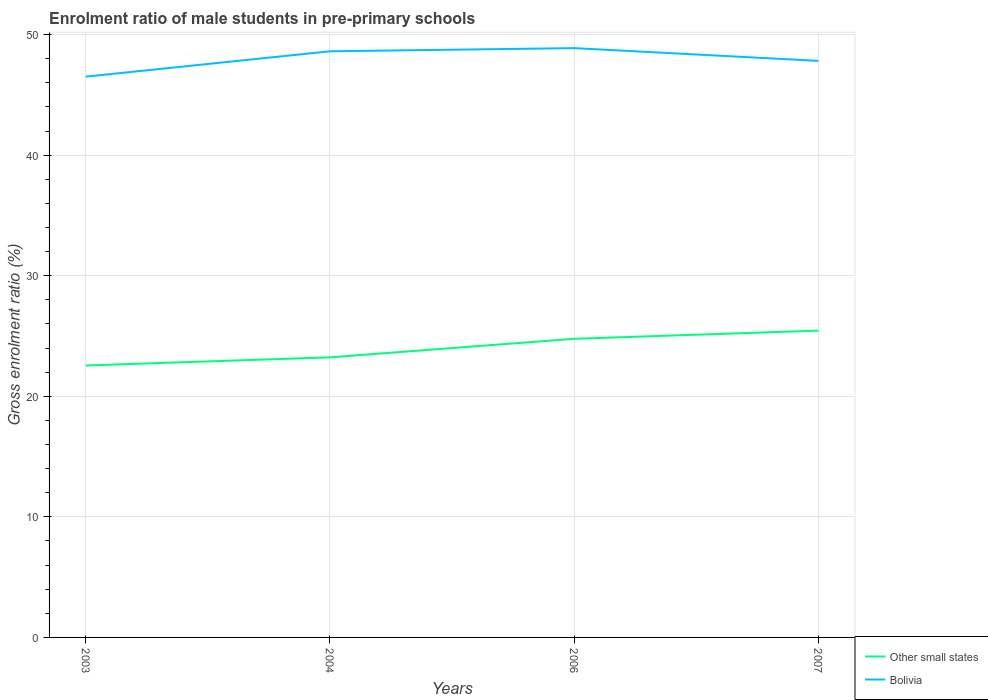How many different coloured lines are there?
Offer a terse response. 2. Is the number of lines equal to the number of legend labels?
Offer a very short reply. Yes. Across all years, what is the maximum enrolment ratio of male students in pre-primary schools in Other small states?
Ensure brevity in your answer.  22.55. What is the total enrolment ratio of male students in pre-primary schools in Other small states in the graph?
Your response must be concise. -2.22. What is the difference between the highest and the second highest enrolment ratio of male students in pre-primary schools in Bolivia?
Ensure brevity in your answer.  2.37. What is the difference between the highest and the lowest enrolment ratio of male students in pre-primary schools in Bolivia?
Offer a very short reply. 2. How many lines are there?
Your answer should be very brief. 2. What is the difference between two consecutive major ticks on the Y-axis?
Offer a very short reply. 10. Are the values on the major ticks of Y-axis written in scientific E-notation?
Give a very brief answer. No. Does the graph contain any zero values?
Give a very brief answer. No. What is the title of the graph?
Give a very brief answer. Enrolment ratio of male students in pre-primary schools. Does "Micronesia" appear as one of the legend labels in the graph?
Keep it short and to the point. No. What is the Gross enrolment ratio (%) of Other small states in 2003?
Make the answer very short. 22.55. What is the Gross enrolment ratio (%) in Bolivia in 2003?
Ensure brevity in your answer.  46.51. What is the Gross enrolment ratio (%) in Other small states in 2004?
Provide a short and direct response. 23.23. What is the Gross enrolment ratio (%) in Bolivia in 2004?
Your answer should be compact. 48.61. What is the Gross enrolment ratio (%) of Other small states in 2006?
Keep it short and to the point. 24.77. What is the Gross enrolment ratio (%) in Bolivia in 2006?
Make the answer very short. 48.88. What is the Gross enrolment ratio (%) of Other small states in 2007?
Provide a succinct answer. 25.45. What is the Gross enrolment ratio (%) in Bolivia in 2007?
Give a very brief answer. 47.82. Across all years, what is the maximum Gross enrolment ratio (%) in Other small states?
Ensure brevity in your answer.  25.45. Across all years, what is the maximum Gross enrolment ratio (%) in Bolivia?
Keep it short and to the point. 48.88. Across all years, what is the minimum Gross enrolment ratio (%) in Other small states?
Offer a very short reply. 22.55. Across all years, what is the minimum Gross enrolment ratio (%) of Bolivia?
Your answer should be compact. 46.51. What is the total Gross enrolment ratio (%) of Other small states in the graph?
Keep it short and to the point. 96. What is the total Gross enrolment ratio (%) of Bolivia in the graph?
Give a very brief answer. 191.82. What is the difference between the Gross enrolment ratio (%) in Other small states in 2003 and that in 2004?
Your answer should be very brief. -0.68. What is the difference between the Gross enrolment ratio (%) of Bolivia in 2003 and that in 2004?
Your response must be concise. -2.1. What is the difference between the Gross enrolment ratio (%) in Other small states in 2003 and that in 2006?
Provide a succinct answer. -2.21. What is the difference between the Gross enrolment ratio (%) of Bolivia in 2003 and that in 2006?
Offer a very short reply. -2.37. What is the difference between the Gross enrolment ratio (%) of Other small states in 2003 and that in 2007?
Your answer should be compact. -2.89. What is the difference between the Gross enrolment ratio (%) in Bolivia in 2003 and that in 2007?
Provide a short and direct response. -1.31. What is the difference between the Gross enrolment ratio (%) of Other small states in 2004 and that in 2006?
Your answer should be compact. -1.54. What is the difference between the Gross enrolment ratio (%) of Bolivia in 2004 and that in 2006?
Your answer should be compact. -0.26. What is the difference between the Gross enrolment ratio (%) of Other small states in 2004 and that in 2007?
Your response must be concise. -2.22. What is the difference between the Gross enrolment ratio (%) in Bolivia in 2004 and that in 2007?
Offer a terse response. 0.79. What is the difference between the Gross enrolment ratio (%) in Other small states in 2006 and that in 2007?
Keep it short and to the point. -0.68. What is the difference between the Gross enrolment ratio (%) in Bolivia in 2006 and that in 2007?
Provide a short and direct response. 1.06. What is the difference between the Gross enrolment ratio (%) in Other small states in 2003 and the Gross enrolment ratio (%) in Bolivia in 2004?
Ensure brevity in your answer.  -26.06. What is the difference between the Gross enrolment ratio (%) in Other small states in 2003 and the Gross enrolment ratio (%) in Bolivia in 2006?
Your answer should be compact. -26.32. What is the difference between the Gross enrolment ratio (%) of Other small states in 2003 and the Gross enrolment ratio (%) of Bolivia in 2007?
Your answer should be compact. -25.26. What is the difference between the Gross enrolment ratio (%) in Other small states in 2004 and the Gross enrolment ratio (%) in Bolivia in 2006?
Your response must be concise. -25.64. What is the difference between the Gross enrolment ratio (%) in Other small states in 2004 and the Gross enrolment ratio (%) in Bolivia in 2007?
Offer a very short reply. -24.59. What is the difference between the Gross enrolment ratio (%) of Other small states in 2006 and the Gross enrolment ratio (%) of Bolivia in 2007?
Your response must be concise. -23.05. What is the average Gross enrolment ratio (%) of Other small states per year?
Provide a short and direct response. 24. What is the average Gross enrolment ratio (%) in Bolivia per year?
Offer a very short reply. 47.95. In the year 2003, what is the difference between the Gross enrolment ratio (%) in Other small states and Gross enrolment ratio (%) in Bolivia?
Keep it short and to the point. -23.95. In the year 2004, what is the difference between the Gross enrolment ratio (%) in Other small states and Gross enrolment ratio (%) in Bolivia?
Your response must be concise. -25.38. In the year 2006, what is the difference between the Gross enrolment ratio (%) of Other small states and Gross enrolment ratio (%) of Bolivia?
Give a very brief answer. -24.11. In the year 2007, what is the difference between the Gross enrolment ratio (%) in Other small states and Gross enrolment ratio (%) in Bolivia?
Ensure brevity in your answer.  -22.37. What is the ratio of the Gross enrolment ratio (%) in Other small states in 2003 to that in 2004?
Ensure brevity in your answer.  0.97. What is the ratio of the Gross enrolment ratio (%) of Bolivia in 2003 to that in 2004?
Ensure brevity in your answer.  0.96. What is the ratio of the Gross enrolment ratio (%) in Other small states in 2003 to that in 2006?
Offer a terse response. 0.91. What is the ratio of the Gross enrolment ratio (%) in Bolivia in 2003 to that in 2006?
Provide a succinct answer. 0.95. What is the ratio of the Gross enrolment ratio (%) in Other small states in 2003 to that in 2007?
Your answer should be compact. 0.89. What is the ratio of the Gross enrolment ratio (%) in Bolivia in 2003 to that in 2007?
Give a very brief answer. 0.97. What is the ratio of the Gross enrolment ratio (%) of Other small states in 2004 to that in 2006?
Keep it short and to the point. 0.94. What is the ratio of the Gross enrolment ratio (%) of Bolivia in 2004 to that in 2006?
Ensure brevity in your answer.  0.99. What is the ratio of the Gross enrolment ratio (%) in Other small states in 2004 to that in 2007?
Ensure brevity in your answer.  0.91. What is the ratio of the Gross enrolment ratio (%) of Bolivia in 2004 to that in 2007?
Provide a succinct answer. 1.02. What is the ratio of the Gross enrolment ratio (%) of Other small states in 2006 to that in 2007?
Provide a succinct answer. 0.97. What is the ratio of the Gross enrolment ratio (%) in Bolivia in 2006 to that in 2007?
Offer a terse response. 1.02. What is the difference between the highest and the second highest Gross enrolment ratio (%) of Other small states?
Make the answer very short. 0.68. What is the difference between the highest and the second highest Gross enrolment ratio (%) of Bolivia?
Your answer should be compact. 0.26. What is the difference between the highest and the lowest Gross enrolment ratio (%) of Other small states?
Provide a succinct answer. 2.89. What is the difference between the highest and the lowest Gross enrolment ratio (%) of Bolivia?
Make the answer very short. 2.37. 